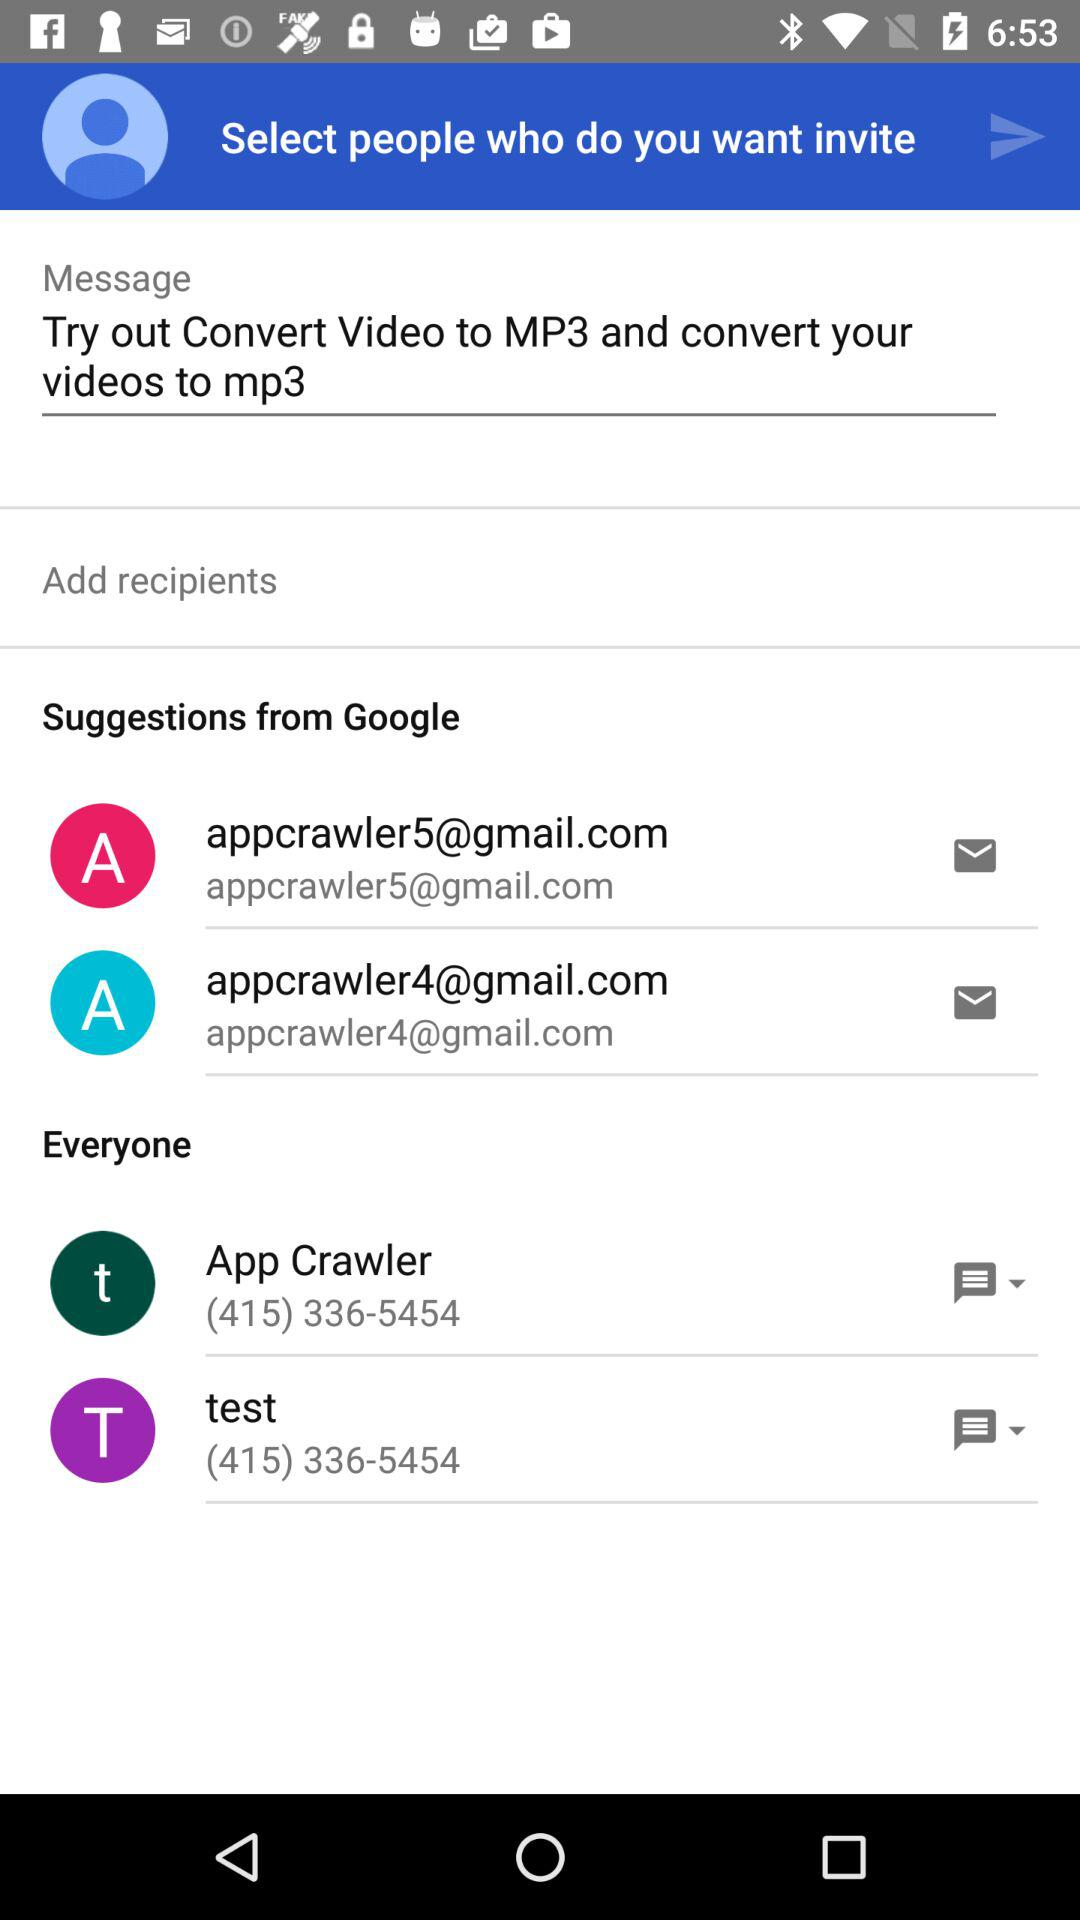What is the contact number of app crawler? The contact number is (415) 336-5454. 